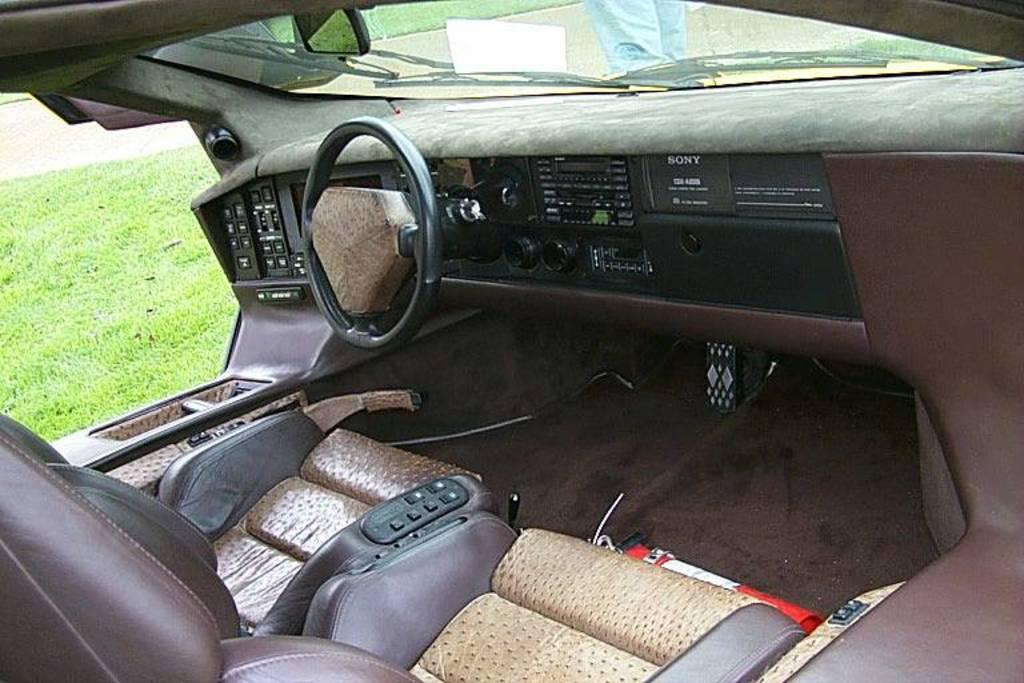Where was the image taken? The image was taken inside a car. What can be seen on the left side of the image? There is a grassland visible on the left side of the image. Can you describe the person in the image? There is a person standing in the front of the image. What type of business is being conducted in the image? There is no indication of any business being conducted in the image. Can you tell me what kind of berry is growing on the grassland in the image? There is no berry visible in the image; only a grassland can be seen. 